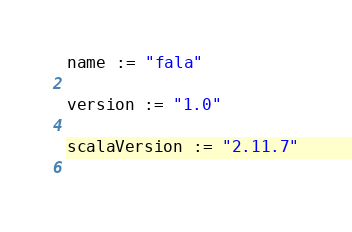Convert code to text. <code><loc_0><loc_0><loc_500><loc_500><_Scala_>name := "fala"

version := "1.0"

scalaVersion := "2.11.7"
    </code> 